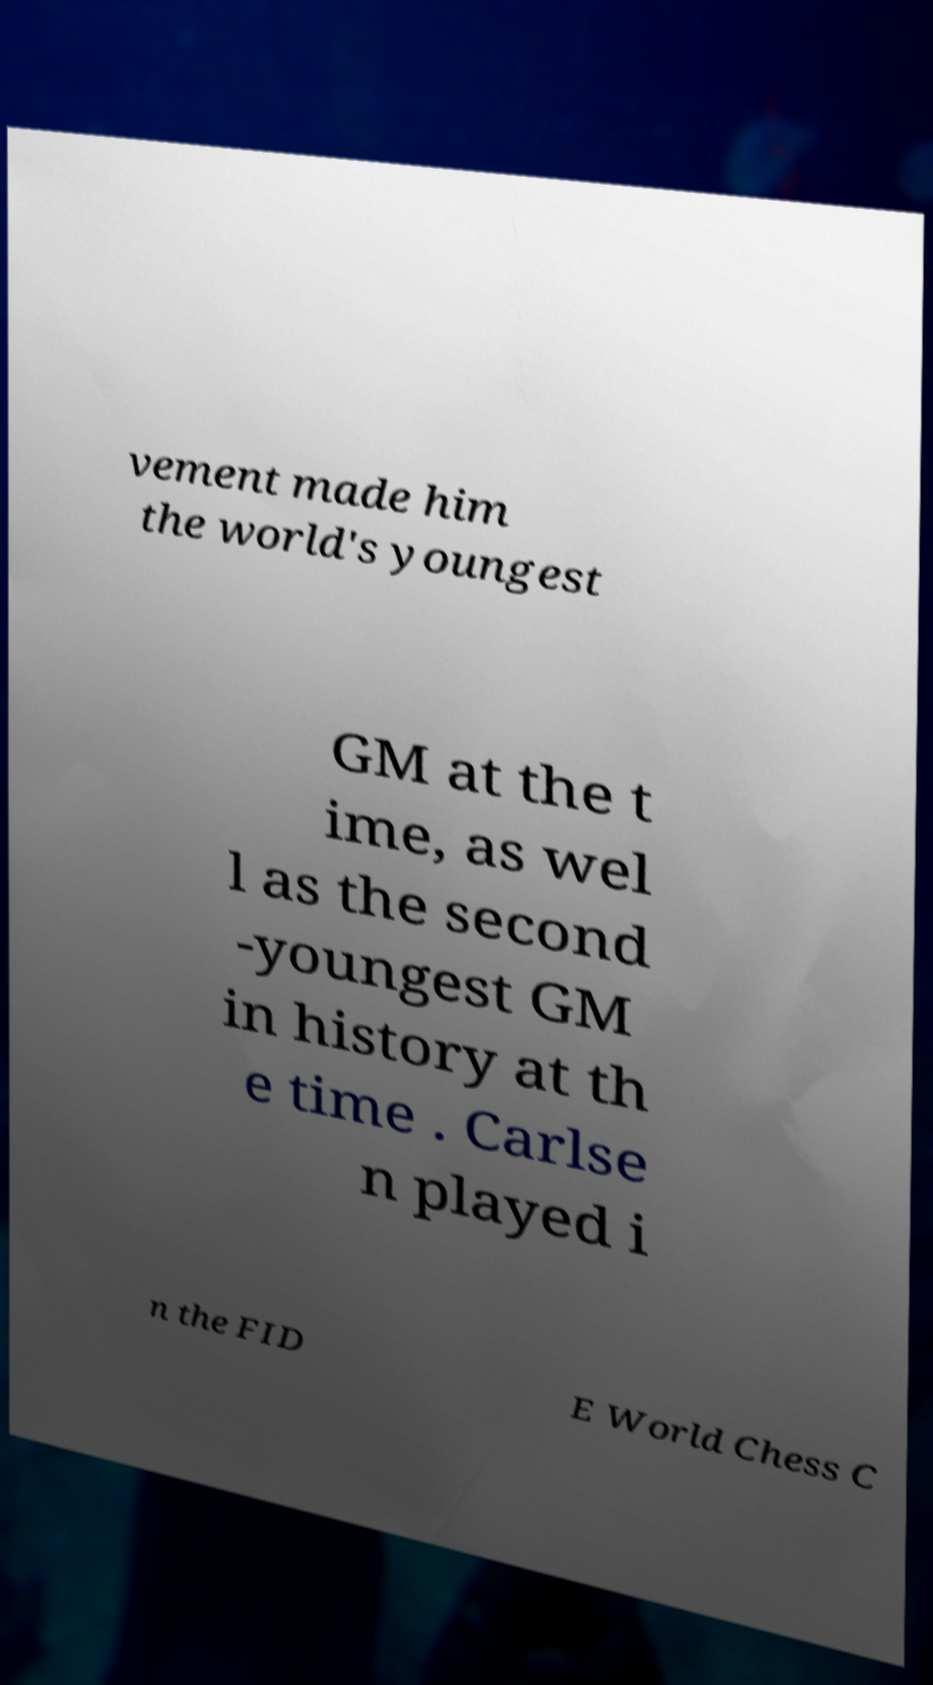Can you read and provide the text displayed in the image?This photo seems to have some interesting text. Can you extract and type it out for me? vement made him the world's youngest GM at the t ime, as wel l as the second -youngest GM in history at th e time . Carlse n played i n the FID E World Chess C 